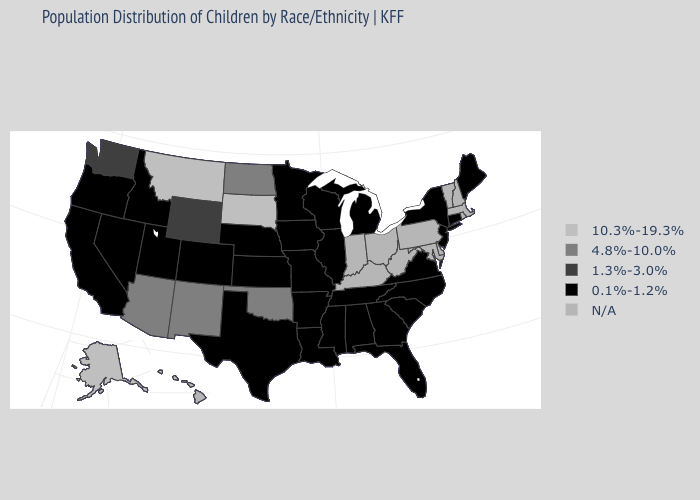Which states hav the highest value in the MidWest?
Concise answer only. South Dakota. Name the states that have a value in the range N/A?
Keep it brief. Delaware, Hawaii, Indiana, Kentucky, Maryland, Massachusetts, New Hampshire, Ohio, Pennsylvania, Rhode Island, Vermont, West Virginia. Does the first symbol in the legend represent the smallest category?
Quick response, please. No. Among the states that border Texas , which have the lowest value?
Write a very short answer. Arkansas, Louisiana. Name the states that have a value in the range N/A?
Be succinct. Delaware, Hawaii, Indiana, Kentucky, Maryland, Massachusetts, New Hampshire, Ohio, Pennsylvania, Rhode Island, Vermont, West Virginia. What is the value of New Jersey?
Quick response, please. 0.1%-1.2%. Which states have the highest value in the USA?
Keep it brief. Alaska, Montana, South Dakota. Name the states that have a value in the range 10.3%-19.3%?
Answer briefly. Alaska, Montana, South Dakota. What is the value of Tennessee?
Be succinct. 0.1%-1.2%. Name the states that have a value in the range 10.3%-19.3%?
Answer briefly. Alaska, Montana, South Dakota. What is the value of New Mexico?
Quick response, please. 4.8%-10.0%. What is the value of Illinois?
Short answer required. 0.1%-1.2%. Name the states that have a value in the range 0.1%-1.2%?
Answer briefly. Alabama, Arkansas, California, Colorado, Connecticut, Florida, Georgia, Idaho, Illinois, Iowa, Kansas, Louisiana, Maine, Michigan, Minnesota, Mississippi, Missouri, Nebraska, Nevada, New Jersey, New York, North Carolina, Oregon, South Carolina, Tennessee, Texas, Utah, Virginia, Wisconsin. Name the states that have a value in the range N/A?
Give a very brief answer. Delaware, Hawaii, Indiana, Kentucky, Maryland, Massachusetts, New Hampshire, Ohio, Pennsylvania, Rhode Island, Vermont, West Virginia. What is the lowest value in the USA?
Keep it brief. 0.1%-1.2%. 